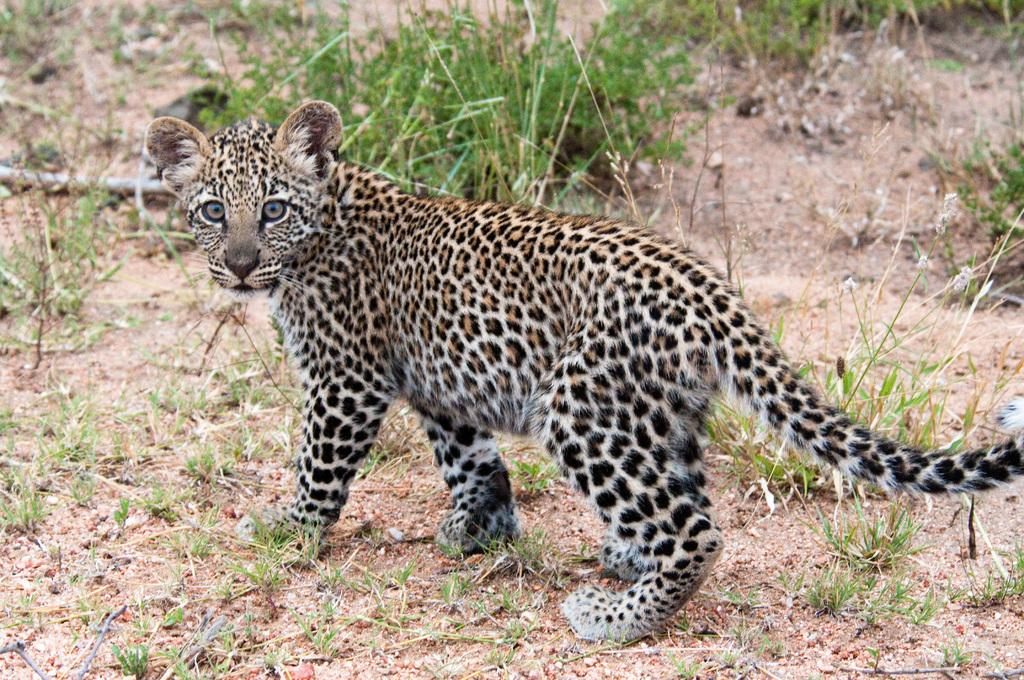What type of animal is in the image? There is a leopard in the image. What is the ground covered with in the image? There is grass on the ground in the image. What organization does the leopard work for in the image? The image does not depict the leopard working for any organization; it is simply an animal in its natural habitat. 